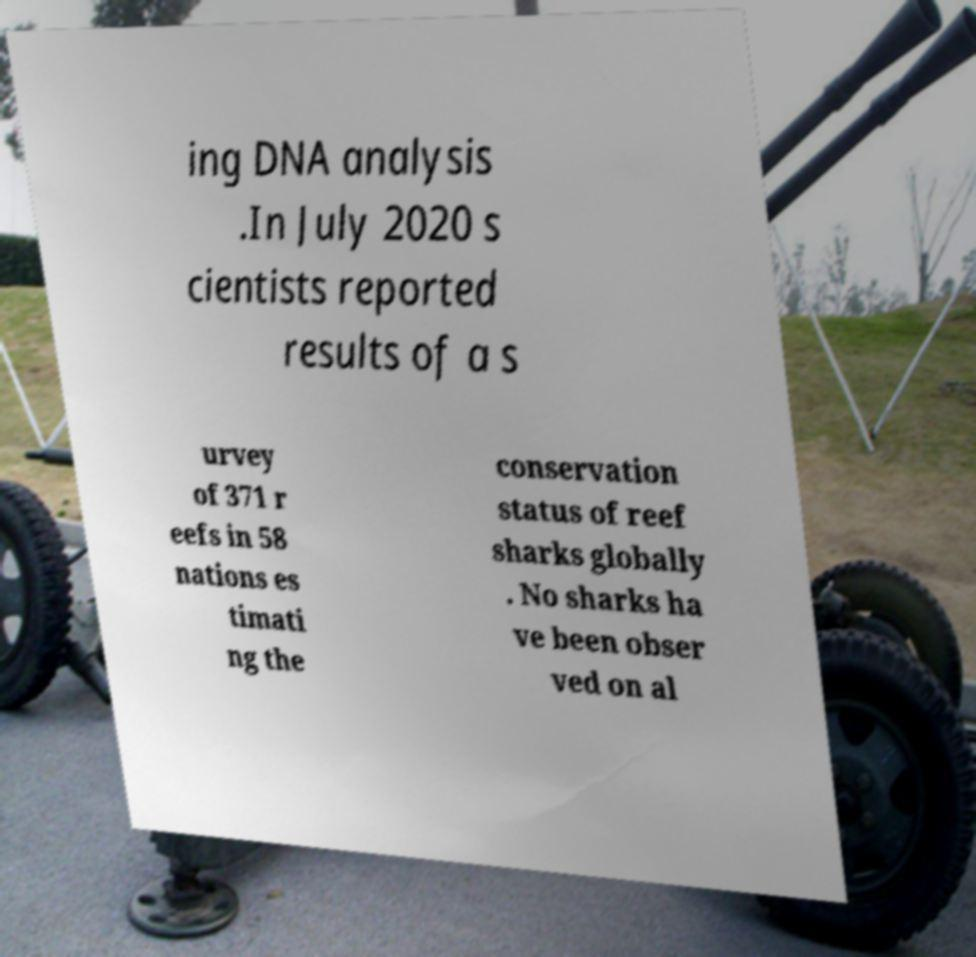Could you extract and type out the text from this image? ing DNA analysis .In July 2020 s cientists reported results of a s urvey of 371 r eefs in 58 nations es timati ng the conservation status of reef sharks globally . No sharks ha ve been obser ved on al 